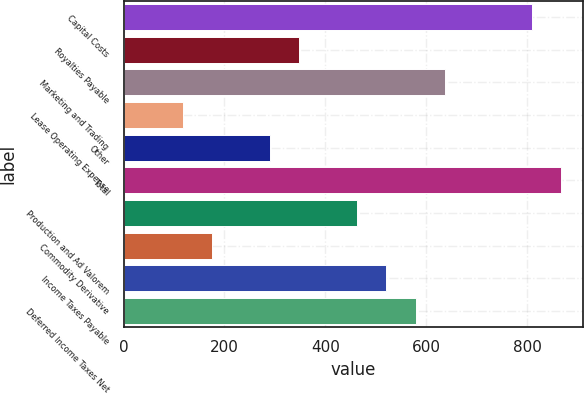Convert chart. <chart><loc_0><loc_0><loc_500><loc_500><bar_chart><fcel>Capital Costs<fcel>Royalties Payable<fcel>Marketing and Trading<fcel>Lease Operating Expense<fcel>Other<fcel>Total<fcel>Production and Ad Valorem<fcel>Commodity Derivative<fcel>Income Taxes Payable<fcel>Deferred Income Taxes Net<nl><fcel>809.8<fcel>348.2<fcel>636.7<fcel>117.4<fcel>290.5<fcel>867.5<fcel>463.6<fcel>175.1<fcel>521.3<fcel>579<nl></chart> 